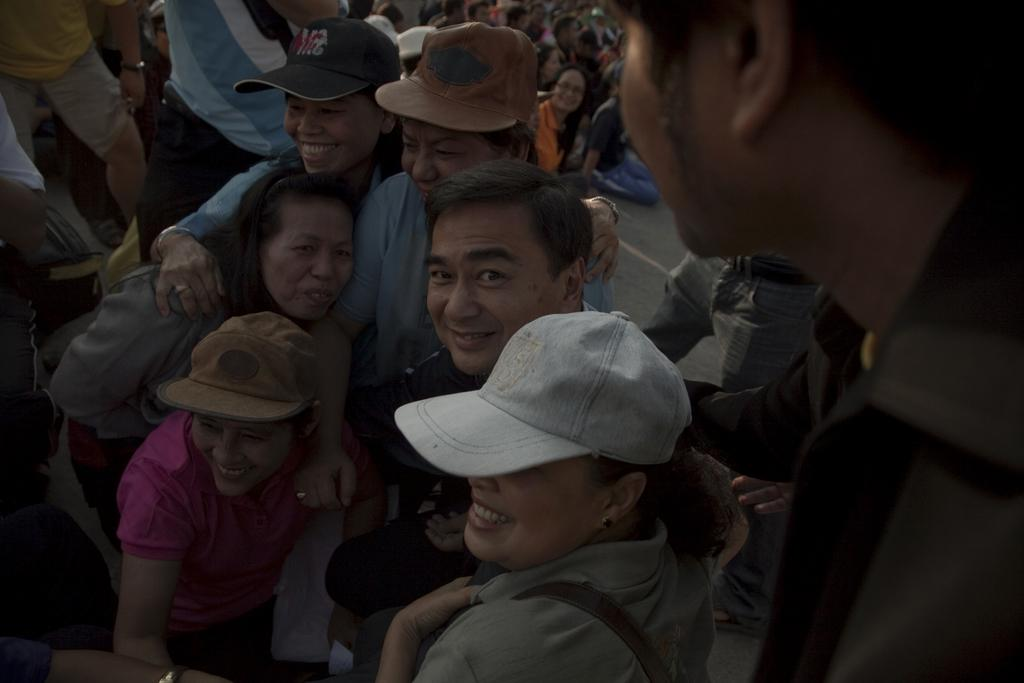What is the main subject of the image? The main subject of the image is a group of people. Can you describe any specific details about the people in the image? Some people in the group are wearing caps. How many houses are visible in the image? There are no houses visible in the image; it features a group of people. What type of camp can be seen in the background of the image? There is no camp present in the image; it features a group of people. 